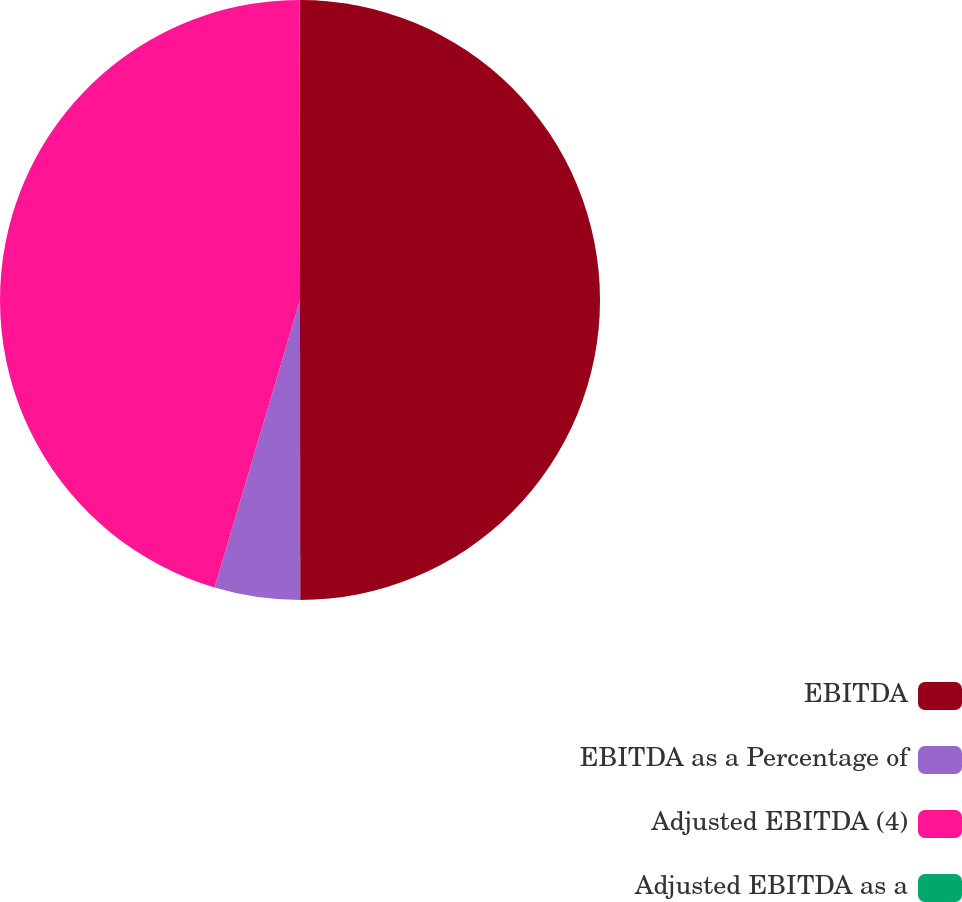Convert chart to OTSL. <chart><loc_0><loc_0><loc_500><loc_500><pie_chart><fcel>EBITDA<fcel>EBITDA as a Percentage of<fcel>Adjusted EBITDA (4)<fcel>Adjusted EBITDA as a<nl><fcel>49.99%<fcel>4.61%<fcel>45.39%<fcel>0.01%<nl></chart> 